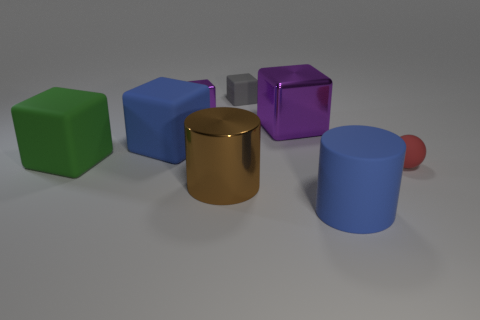Subtract all brown cylinders. How many purple blocks are left? 2 Subtract all large purple blocks. How many blocks are left? 4 Subtract 2 blocks. How many blocks are left? 3 Subtract all blue blocks. How many blocks are left? 4 Subtract all yellow cubes. Subtract all cyan cylinders. How many cubes are left? 5 Add 2 cyan matte cylinders. How many objects exist? 10 Subtract all cylinders. How many objects are left? 6 Subtract all large metal cylinders. Subtract all big cylinders. How many objects are left? 5 Add 7 red balls. How many red balls are left? 8 Add 5 small gray rubber blocks. How many small gray rubber blocks exist? 6 